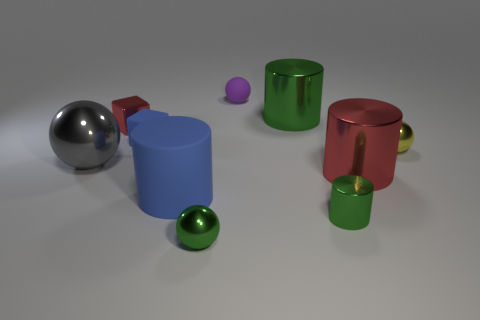Subtract all gray spheres. How many green cylinders are left? 2 Subtract 1 balls. How many balls are left? 3 Subtract all big green cylinders. How many cylinders are left? 3 Subtract all blue cylinders. How many cylinders are left? 3 Subtract all purple cylinders. Subtract all red balls. How many cylinders are left? 4 Subtract all cylinders. How many objects are left? 6 Subtract 0 cyan cylinders. How many objects are left? 10 Subtract all large blue shiny cylinders. Subtract all shiny objects. How many objects are left? 3 Add 5 large green metal things. How many large green metal things are left? 6 Add 1 small red shiny objects. How many small red shiny objects exist? 2 